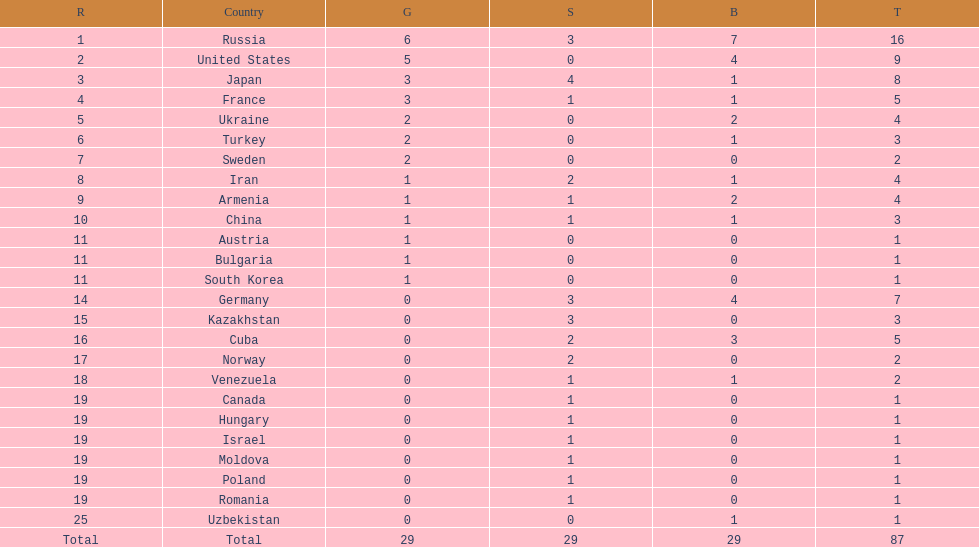Who ranked right after turkey? Sweden. 